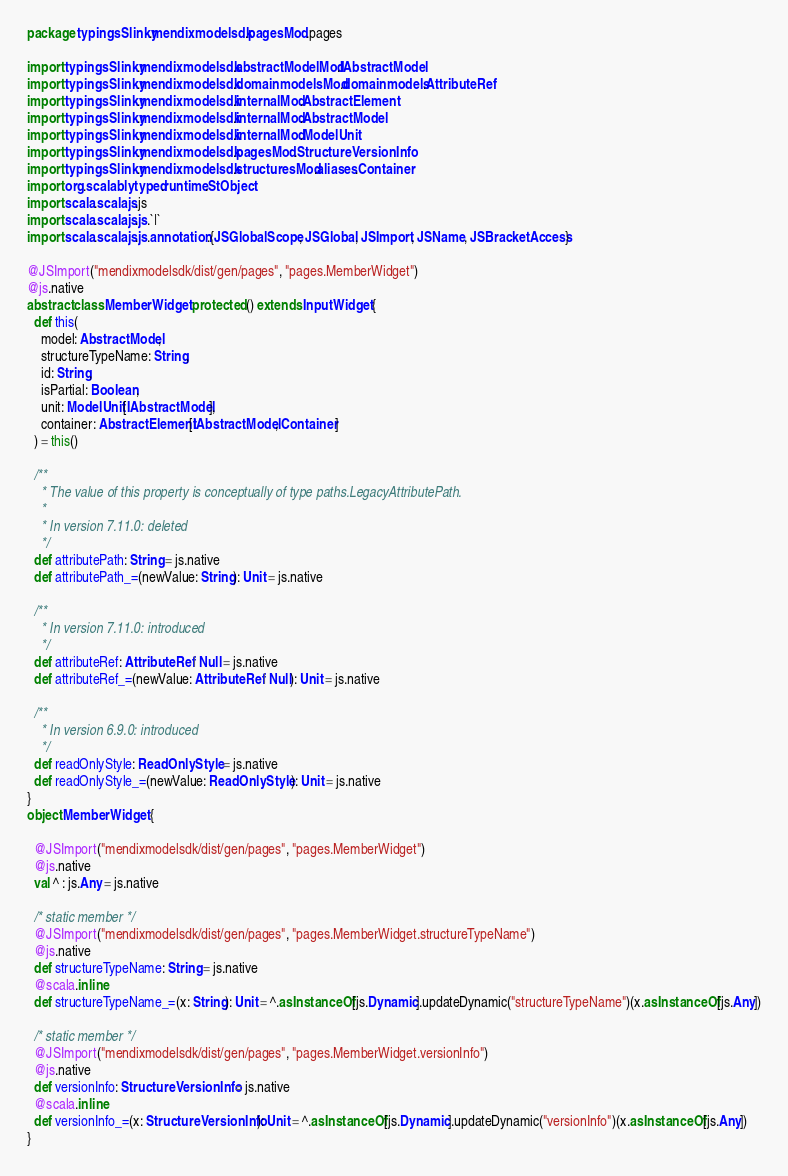Convert code to text. <code><loc_0><loc_0><loc_500><loc_500><_Scala_>package typingsSlinky.mendixmodelsdk.pagesMod.pages

import typingsSlinky.mendixmodelsdk.abstractModelMod.IAbstractModel
import typingsSlinky.mendixmodelsdk.domainmodelsMod.domainmodels.AttributeRef
import typingsSlinky.mendixmodelsdk.internalMod.AbstractElement
import typingsSlinky.mendixmodelsdk.internalMod.AbstractModel
import typingsSlinky.mendixmodelsdk.internalMod.ModelUnit
import typingsSlinky.mendixmodelsdk.pagesMod.StructureVersionInfo
import typingsSlinky.mendixmodelsdk.structuresMod.aliases.Container
import org.scalablytyped.runtime.StObject
import scala.scalajs.js
import scala.scalajs.js.`|`
import scala.scalajs.js.annotation.{JSGlobalScope, JSGlobal, JSImport, JSName, JSBracketAccess}

@JSImport("mendixmodelsdk/dist/gen/pages", "pages.MemberWidget")
@js.native
abstract class MemberWidget protected () extends InputWidget {
  def this(
    model: AbstractModel,
    structureTypeName: String,
    id: String,
    isPartial: Boolean,
    unit: ModelUnit[IAbstractModel],
    container: AbstractElement[IAbstractModel, Container]
  ) = this()
  
  /**
    * The value of this property is conceptually of type paths.LegacyAttributePath.
    *
    * In version 7.11.0: deleted
    */
  def attributePath: String = js.native
  def attributePath_=(newValue: String): Unit = js.native
  
  /**
    * In version 7.11.0: introduced
    */
  def attributeRef: AttributeRef | Null = js.native
  def attributeRef_=(newValue: AttributeRef | Null): Unit = js.native
  
  /**
    * In version 6.9.0: introduced
    */
  def readOnlyStyle: ReadOnlyStyle = js.native
  def readOnlyStyle_=(newValue: ReadOnlyStyle): Unit = js.native
}
object MemberWidget {
  
  @JSImport("mendixmodelsdk/dist/gen/pages", "pages.MemberWidget")
  @js.native
  val ^ : js.Any = js.native
  
  /* static member */
  @JSImport("mendixmodelsdk/dist/gen/pages", "pages.MemberWidget.structureTypeName")
  @js.native
  def structureTypeName: String = js.native
  @scala.inline
  def structureTypeName_=(x: String): Unit = ^.asInstanceOf[js.Dynamic].updateDynamic("structureTypeName")(x.asInstanceOf[js.Any])
  
  /* static member */
  @JSImport("mendixmodelsdk/dist/gen/pages", "pages.MemberWidget.versionInfo")
  @js.native
  def versionInfo: StructureVersionInfo = js.native
  @scala.inline
  def versionInfo_=(x: StructureVersionInfo): Unit = ^.asInstanceOf[js.Dynamic].updateDynamic("versionInfo")(x.asInstanceOf[js.Any])
}
</code> 